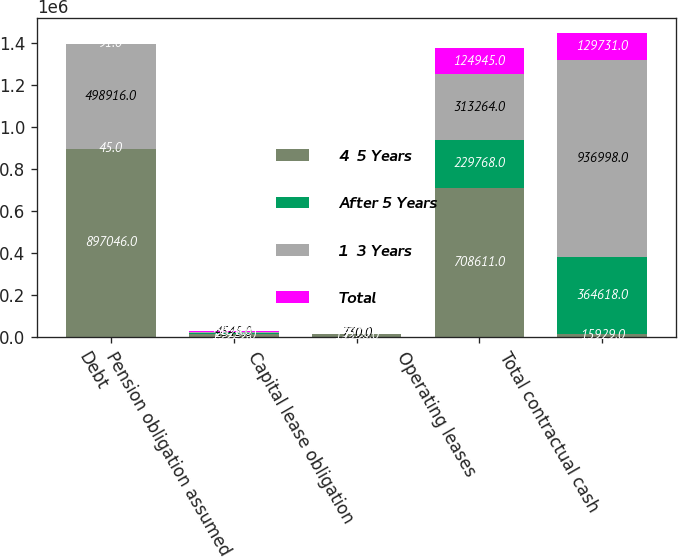Convert chart. <chart><loc_0><loc_0><loc_500><loc_500><stacked_bar_chart><ecel><fcel>Debt<fcel>Pension obligation assumed<fcel>Capital lease obligation<fcel>Operating leases<fcel>Total contractual cash<nl><fcel>4  5 Years<fcel>897046<fcel>15929<fcel>13550<fcel>708611<fcel>15929<nl><fcel>After 5 Years<fcel>45<fcel>2625<fcel>341<fcel>229768<fcel>364618<nl><fcel>1  3 Years<fcel>498916<fcel>4545<fcel>730<fcel>313264<fcel>936998<nl><fcel>Total<fcel>91<fcel>3698<fcel>997<fcel>124945<fcel>129731<nl></chart> 